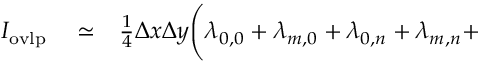<formula> <loc_0><loc_0><loc_500><loc_500>\begin{array} { r l r } { I _ { o v l p } } & \simeq } & { \frac { 1 } { 4 } \Delta x \Delta y \Big ( \lambda _ { 0 , 0 } + \lambda _ { m , 0 } + \lambda _ { 0 , n } + \lambda _ { m , n } + } \end{array}</formula> 